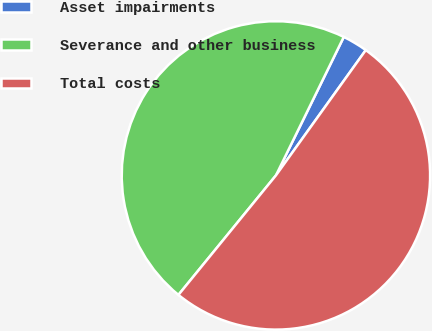Convert chart to OTSL. <chart><loc_0><loc_0><loc_500><loc_500><pie_chart><fcel>Asset impairments<fcel>Severance and other business<fcel>Total costs<nl><fcel>2.65%<fcel>46.36%<fcel>50.99%<nl></chart> 